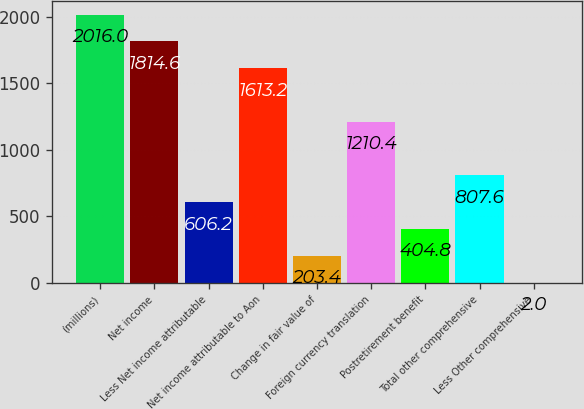Convert chart to OTSL. <chart><loc_0><loc_0><loc_500><loc_500><bar_chart><fcel>(millions)<fcel>Net income<fcel>Less Net income attributable<fcel>Net income attributable to Aon<fcel>Change in fair value of<fcel>Foreign currency translation<fcel>Postretirement benefit<fcel>Total other comprehensive<fcel>Less Other comprehensive<nl><fcel>2016<fcel>1814.6<fcel>606.2<fcel>1613.2<fcel>203.4<fcel>1210.4<fcel>404.8<fcel>807.6<fcel>2<nl></chart> 